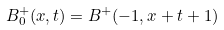<formula> <loc_0><loc_0><loc_500><loc_500>B ^ { + } _ { 0 } ( x , t ) = B ^ { + } ( - 1 , x + t + 1 )</formula> 